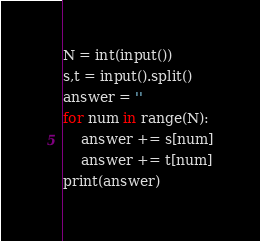Convert code to text. <code><loc_0><loc_0><loc_500><loc_500><_Python_>N = int(input())
s,t = input().split()
answer = ''
for num in range(N):
    answer += s[num]
    answer += t[num]
print(answer)</code> 